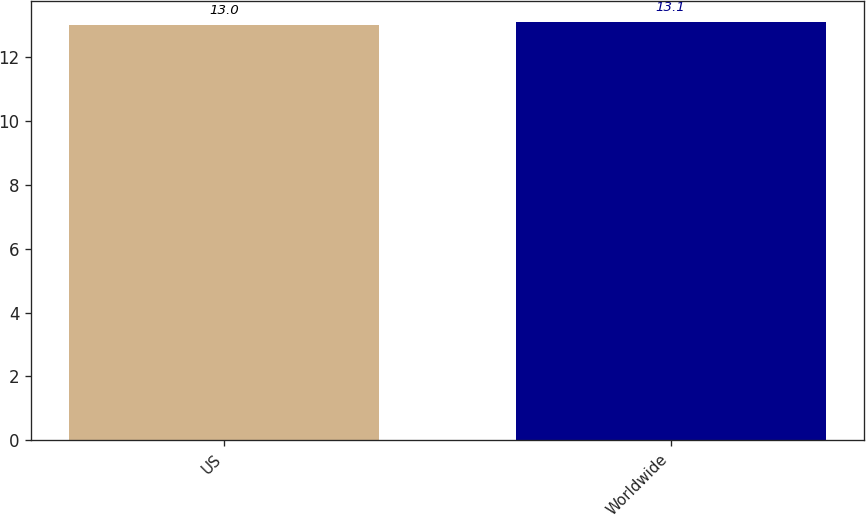<chart> <loc_0><loc_0><loc_500><loc_500><bar_chart><fcel>US<fcel>Worldwide<nl><fcel>13<fcel>13.1<nl></chart> 